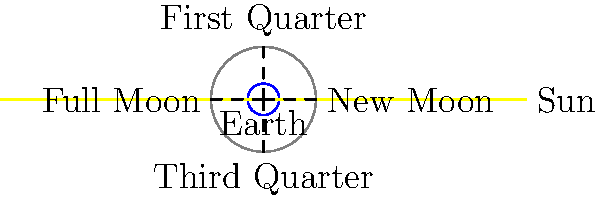An antique orrery in your collection displays the phases of the moon. When examining the position where the moon appears completely illuminated from Earth's perspective, what phase is this called, and at what angle is it positioned relative to the Earth-Sun line? To answer this question, let's follow these steps:

1. Recall that the moon's phases are determined by the relative positions of the Sun, Earth, and Moon.

2. In the orrery diagram:
   - The Sun's light is coming from the right side.
   - The Earth is at the center.
   - The Moon's orbit is represented by the large circle around Earth.

3. The moon is completely illuminated from Earth's perspective when it's on the opposite side of Earth from the Sun. This allows the entire sunlit face of the moon to be visible from Earth.

4. Looking at the diagram, this position is labeled "Full Moon" and is located on the left side of the circle.

5. To determine the angle, we need to consider the Earth-Sun line as our reference (0°).

6. The Full Moon position forms a straight line with the Earth and Sun, on the opposite side of Earth from the Sun.

7. This means the Full Moon is at a 180° angle relative to the Earth-Sun line.

Therefore, the phase shown when the moon appears completely illuminated is the Full Moon, positioned at a 180° angle relative to the Earth-Sun line.
Answer: Full Moon, 180° 